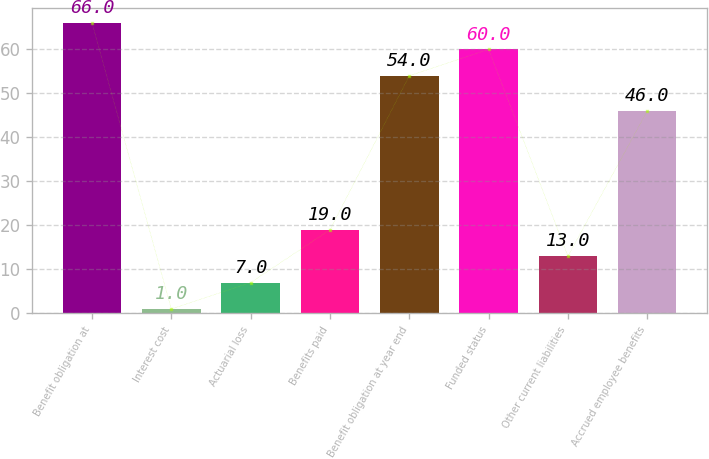Convert chart. <chart><loc_0><loc_0><loc_500><loc_500><bar_chart><fcel>Benefit obligation at<fcel>Interest cost<fcel>Actuarial loss<fcel>Benefits paid<fcel>Benefit obligation at year end<fcel>Funded status<fcel>Other current liabilities<fcel>Accrued employee benefits<nl><fcel>66<fcel>1<fcel>7<fcel>19<fcel>54<fcel>60<fcel>13<fcel>46<nl></chart> 